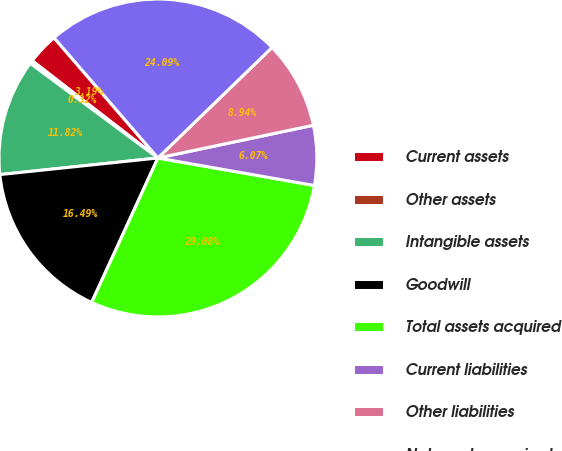<chart> <loc_0><loc_0><loc_500><loc_500><pie_chart><fcel>Current assets<fcel>Other assets<fcel>Intangible assets<fcel>Goodwill<fcel>Total assets acquired<fcel>Current liabilities<fcel>Other liabilities<fcel>Net assets acquired<nl><fcel>3.19%<fcel>0.32%<fcel>11.82%<fcel>16.49%<fcel>29.08%<fcel>6.07%<fcel>8.94%<fcel>24.09%<nl></chart> 